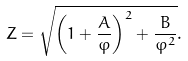<formula> <loc_0><loc_0><loc_500><loc_500>Z = \sqrt { \left ( 1 + \frac { A } { \varphi } \right ) ^ { 2 } + \frac { B } { \varphi ^ { 2 } } } .</formula> 